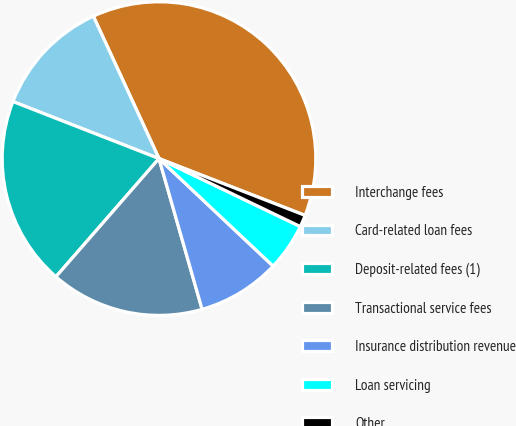<chart> <loc_0><loc_0><loc_500><loc_500><pie_chart><fcel>Interchange fees<fcel>Card-related loan fees<fcel>Deposit-related fees (1)<fcel>Transactional service fees<fcel>Insurance distribution revenue<fcel>Loan servicing<fcel>Other<nl><fcel>37.78%<fcel>12.2%<fcel>19.51%<fcel>15.85%<fcel>8.54%<fcel>4.89%<fcel>1.23%<nl></chart> 